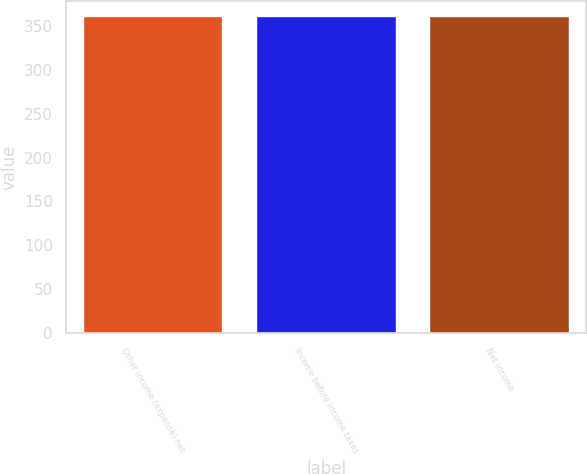Convert chart to OTSL. <chart><loc_0><loc_0><loc_500><loc_500><bar_chart><fcel>Other income (expense) net<fcel>Income before income taxes<fcel>Net income<nl><fcel>360<fcel>360.1<fcel>360.2<nl></chart> 